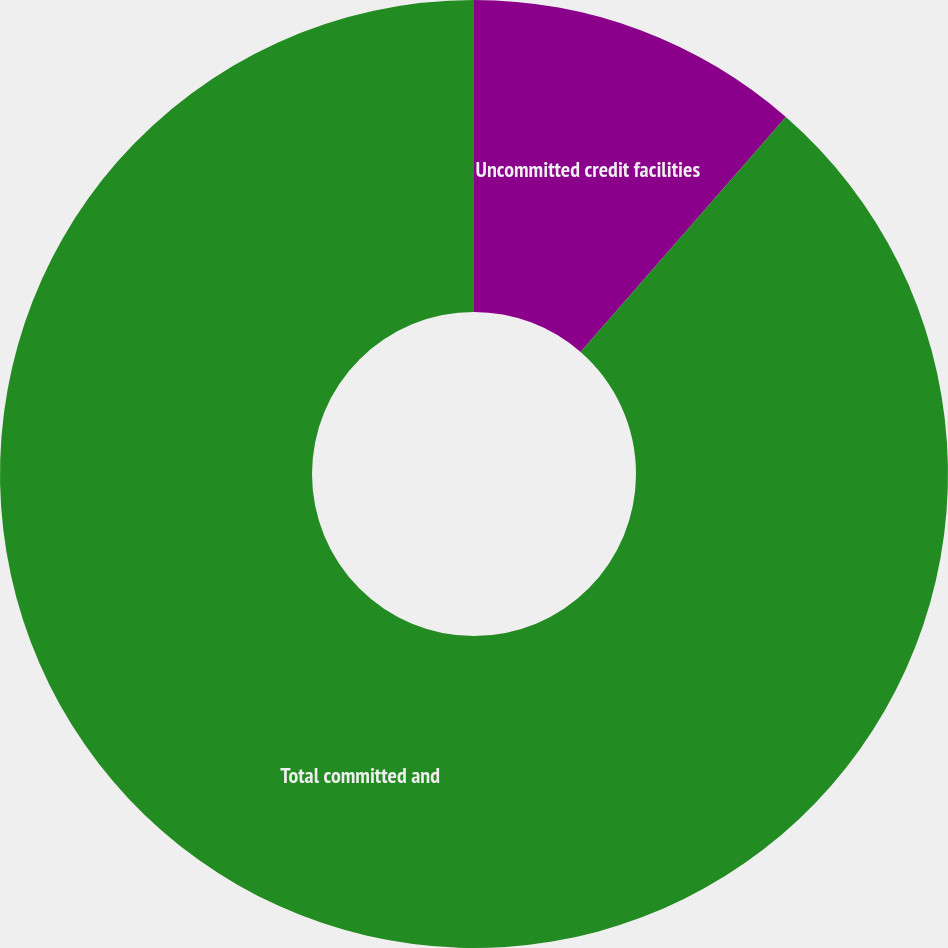<chart> <loc_0><loc_0><loc_500><loc_500><pie_chart><fcel>Uncommitted credit facilities<fcel>Total committed and<nl><fcel>11.43%<fcel>88.57%<nl></chart> 